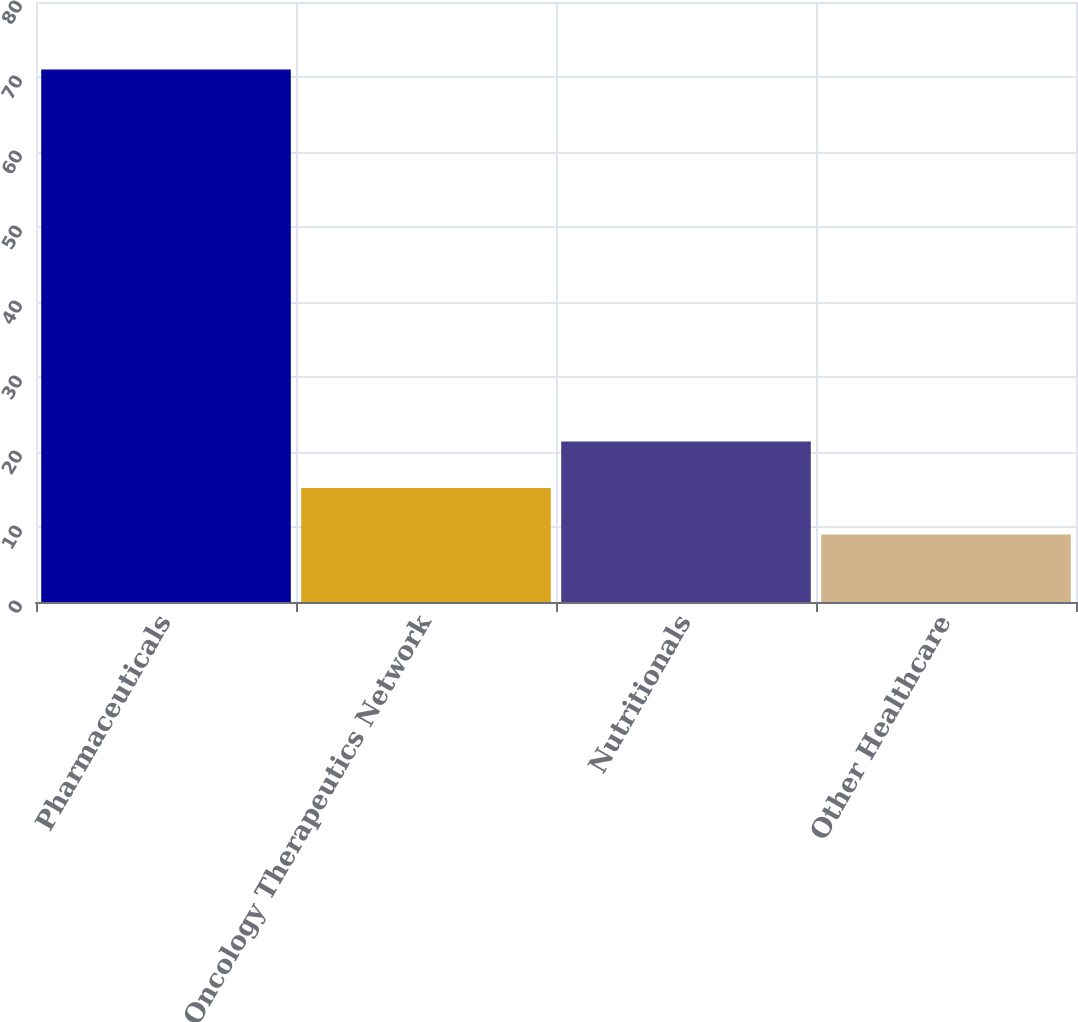Convert chart to OTSL. <chart><loc_0><loc_0><loc_500><loc_500><bar_chart><fcel>Pharmaceuticals<fcel>Oncology Therapeutics Network<fcel>Nutritionals<fcel>Other Healthcare<nl><fcel>71<fcel>15.2<fcel>21.4<fcel>9<nl></chart> 